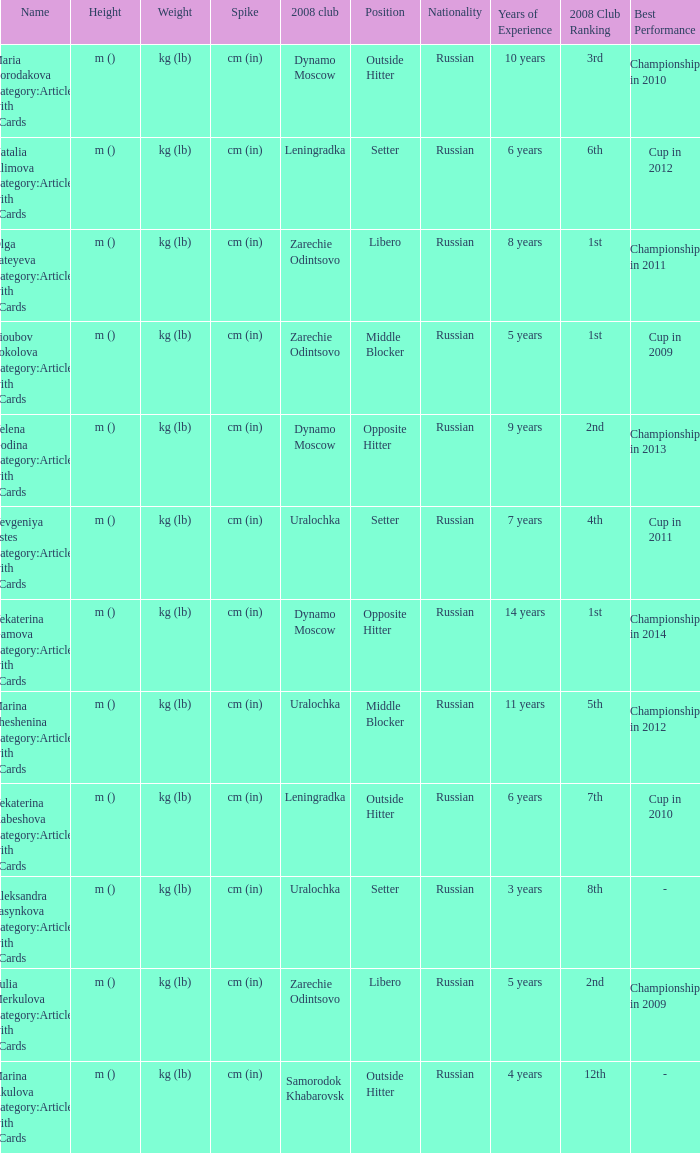What is the name when the 2008 club is uralochka? Yevgeniya Estes Category:Articles with hCards, Marina Sheshenina Category:Articles with hCards, Aleksandra Pasynkova Category:Articles with hCards. 